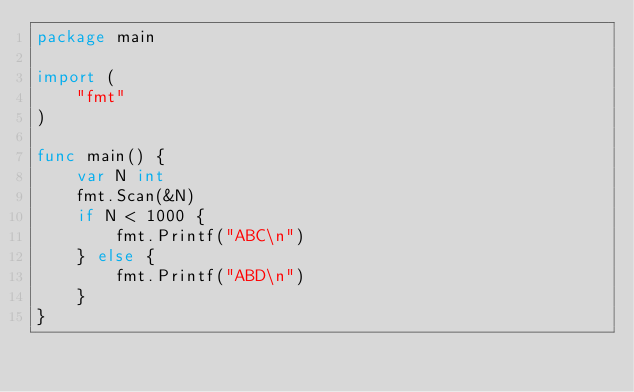Convert code to text. <code><loc_0><loc_0><loc_500><loc_500><_Go_>package main

import (
	"fmt"
)

func main() {
	var N int
	fmt.Scan(&N)
	if N < 1000 {
		fmt.Printf("ABC\n")
	} else {
		fmt.Printf("ABD\n")
	}
}
</code> 